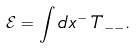Convert formula to latex. <formula><loc_0><loc_0><loc_500><loc_500>\mathcal { E } = \int d x ^ { - } \, T _ { - - } .</formula> 